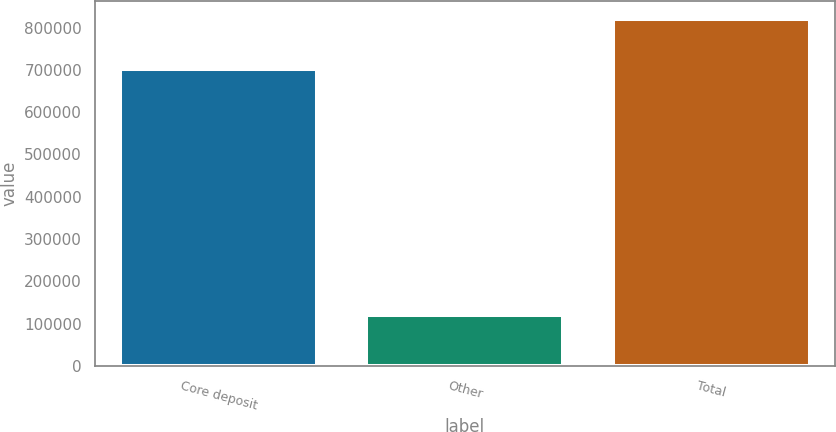Convert chart to OTSL. <chart><loc_0><loc_0><loc_500><loc_500><bar_chart><fcel>Core deposit<fcel>Other<fcel>Total<nl><fcel>701000<fcel>119968<fcel>820968<nl></chart> 